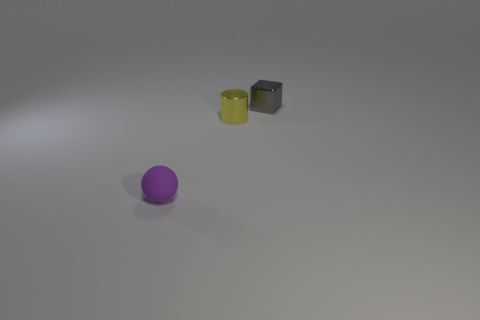Add 2 big green metallic cubes. How many objects exist? 5 Subtract all cylinders. How many objects are left? 2 Add 3 cylinders. How many cylinders exist? 4 Subtract 0 green cylinders. How many objects are left? 3 Subtract all purple spheres. Subtract all big purple matte things. How many objects are left? 2 Add 1 small rubber things. How many small rubber things are left? 2 